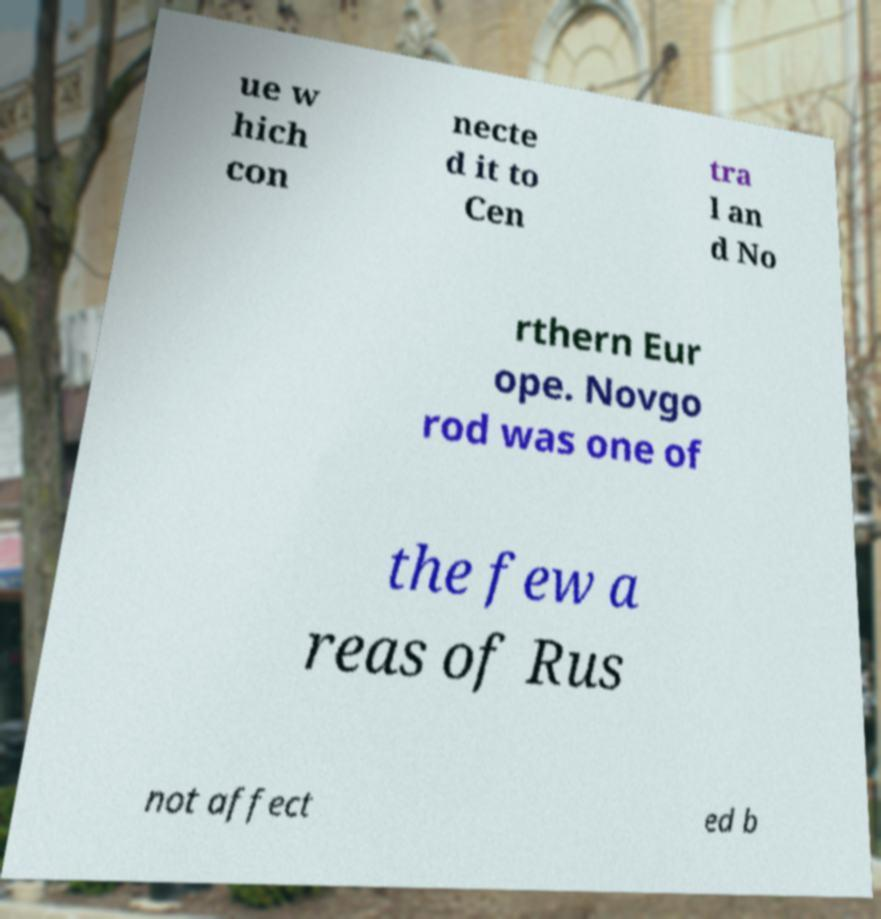I need the written content from this picture converted into text. Can you do that? ue w hich con necte d it to Cen tra l an d No rthern Eur ope. Novgo rod was one of the few a reas of Rus not affect ed b 